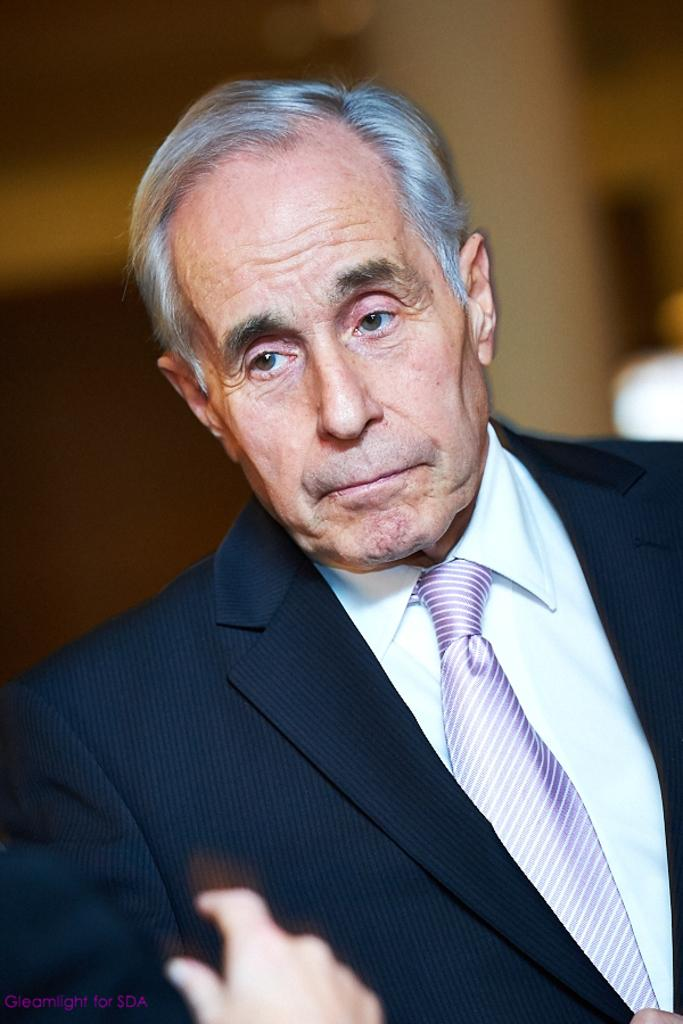What is the main subject of the image? There is a man in the image. Can you describe the man's clothing? The man is wearing a black coat and a tie. Are there any other human body parts visible in the image besides the man? Yes, there is another human hand visible in the image. What type of gun is the man holding in the image? There is no gun present in the image; the man is only wearing a black coat and a tie. Where is the man walking in the image? The image does not show the man walking or any indication of a street or field. 